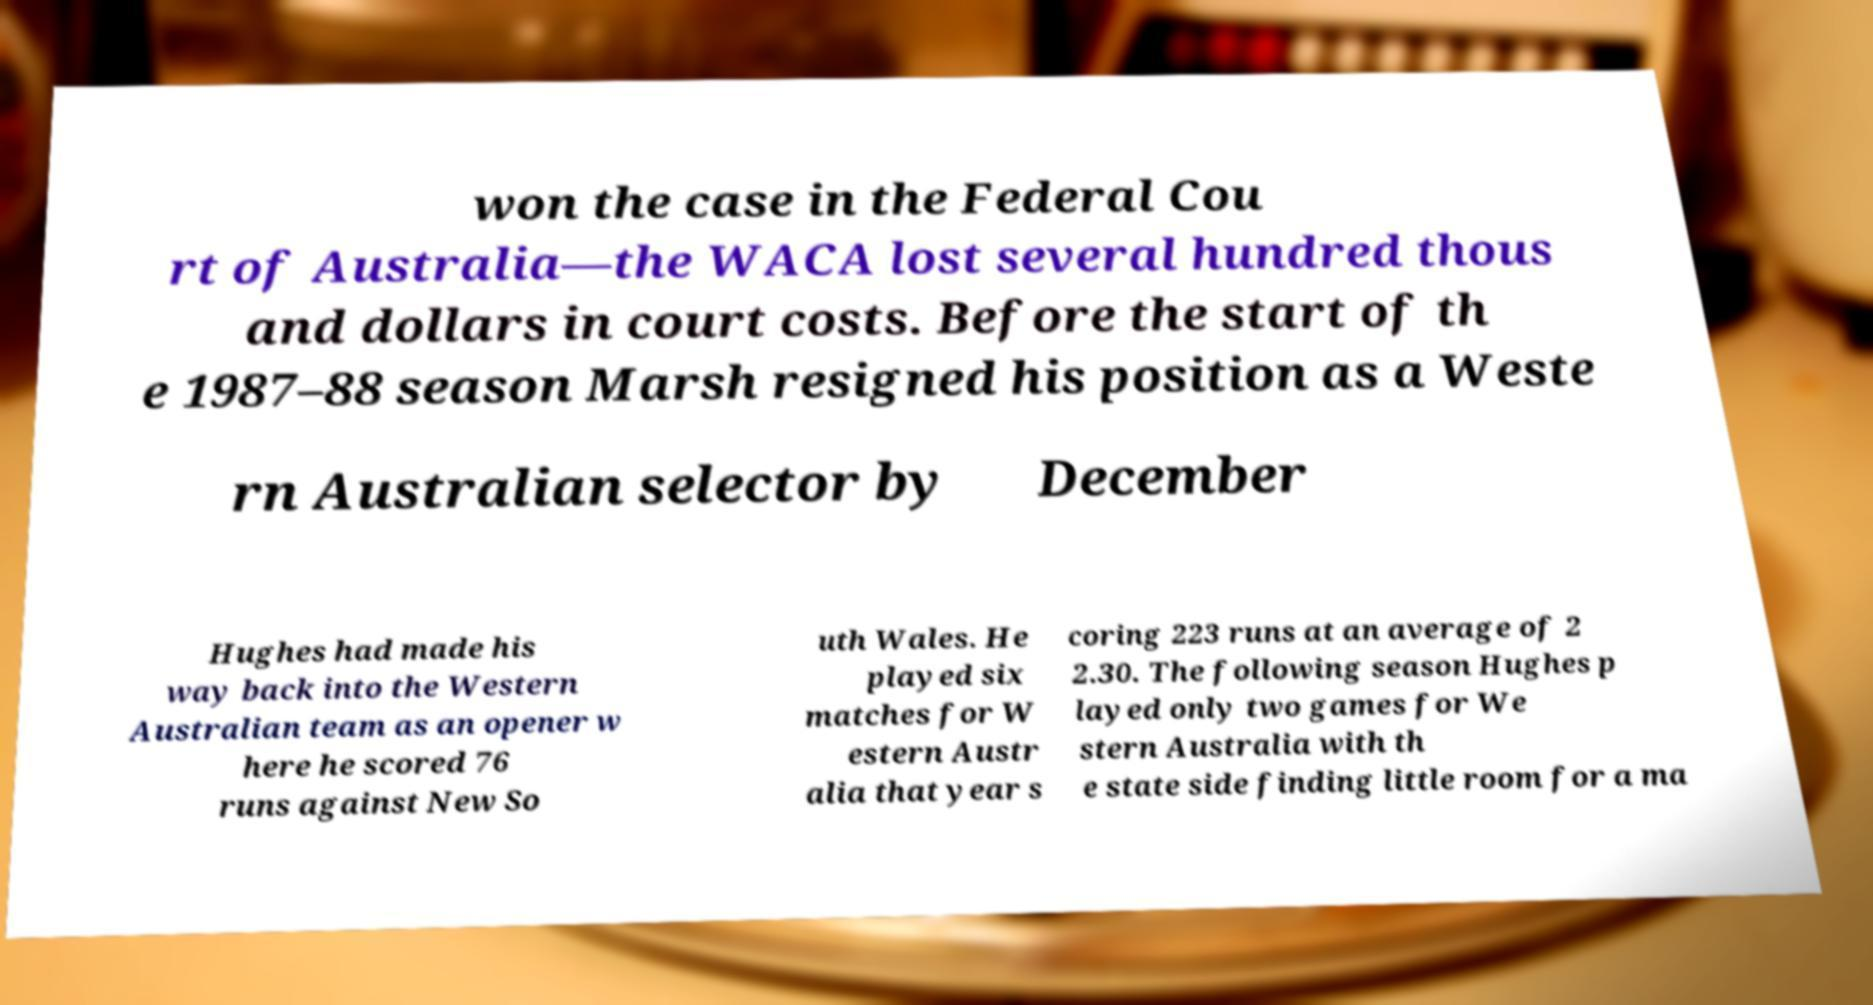Could you extract and type out the text from this image? won the case in the Federal Cou rt of Australia—the WACA lost several hundred thous and dollars in court costs. Before the start of th e 1987–88 season Marsh resigned his position as a Weste rn Australian selector by December Hughes had made his way back into the Western Australian team as an opener w here he scored 76 runs against New So uth Wales. He played six matches for W estern Austr alia that year s coring 223 runs at an average of 2 2.30. The following season Hughes p layed only two games for We stern Australia with th e state side finding little room for a ma 